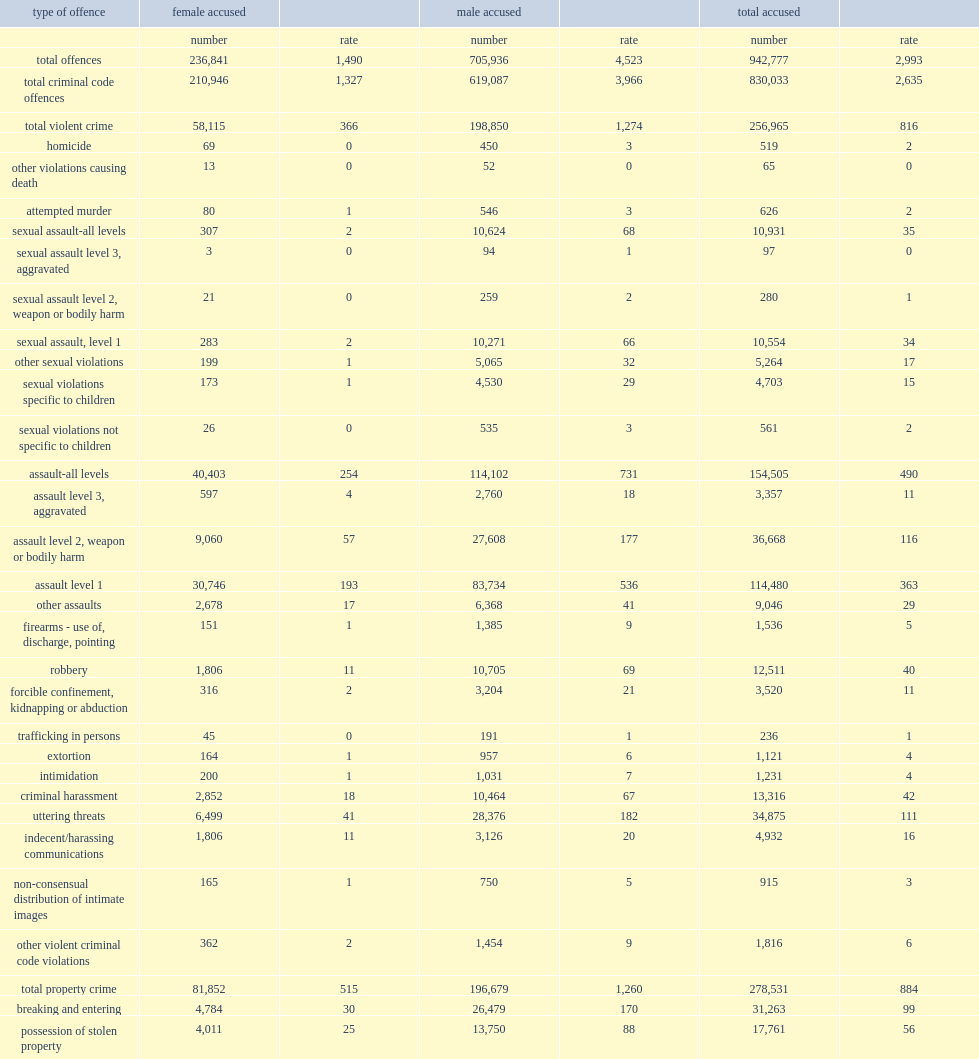How many females aged 12 and older accused of committing a criminal code offence in 2017? 210946.0. In 2017, what percent of all persons accused of a criminal code violation were related to assault. 0.186143. What percent of violent crime involving a female accused being related to assault? 0.695225. Which group of people were accused of sexual assault (levels 1, 2 and 3) far less frequently? males or females? Female accused. 